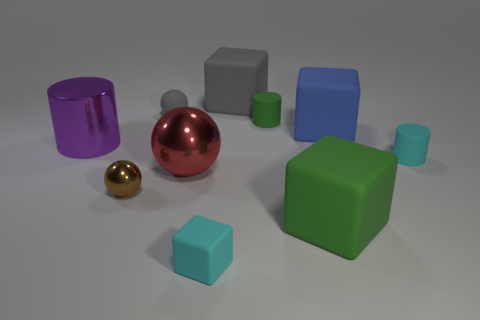There is a block that is the same color as the tiny rubber sphere; what is its material?
Your answer should be very brief. Rubber. Are there fewer small spheres in front of the small green cylinder than large cylinders that are in front of the big metallic ball?
Your answer should be compact. No. What number of other objects are the same shape as the purple metallic thing?
Give a very brief answer. 2. What shape is the purple object that is the same material as the brown thing?
Ensure brevity in your answer.  Cylinder. The large matte cube that is both on the right side of the green rubber cylinder and behind the large purple metal cylinder is what color?
Give a very brief answer. Blue. Are the small cyan object that is on the left side of the big green rubber block and the large red sphere made of the same material?
Keep it short and to the point. No. Is the number of metallic objects behind the gray cube less than the number of small matte spheres?
Provide a succinct answer. Yes. Is there a blue object that has the same material as the large blue cube?
Make the answer very short. No. Is the size of the blue thing the same as the sphere in front of the large red ball?
Your response must be concise. No. Are there any big things of the same color as the tiny matte cube?
Your answer should be very brief. No. 